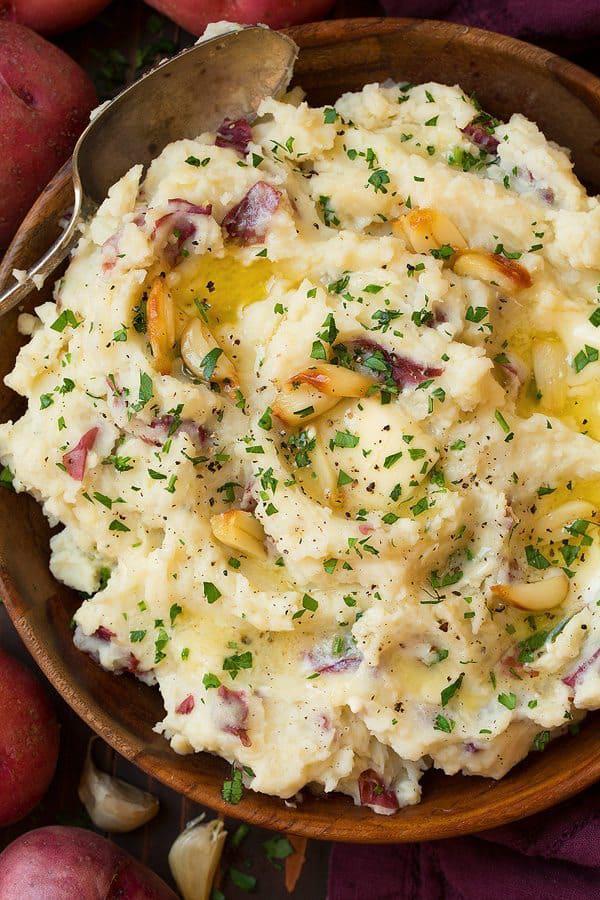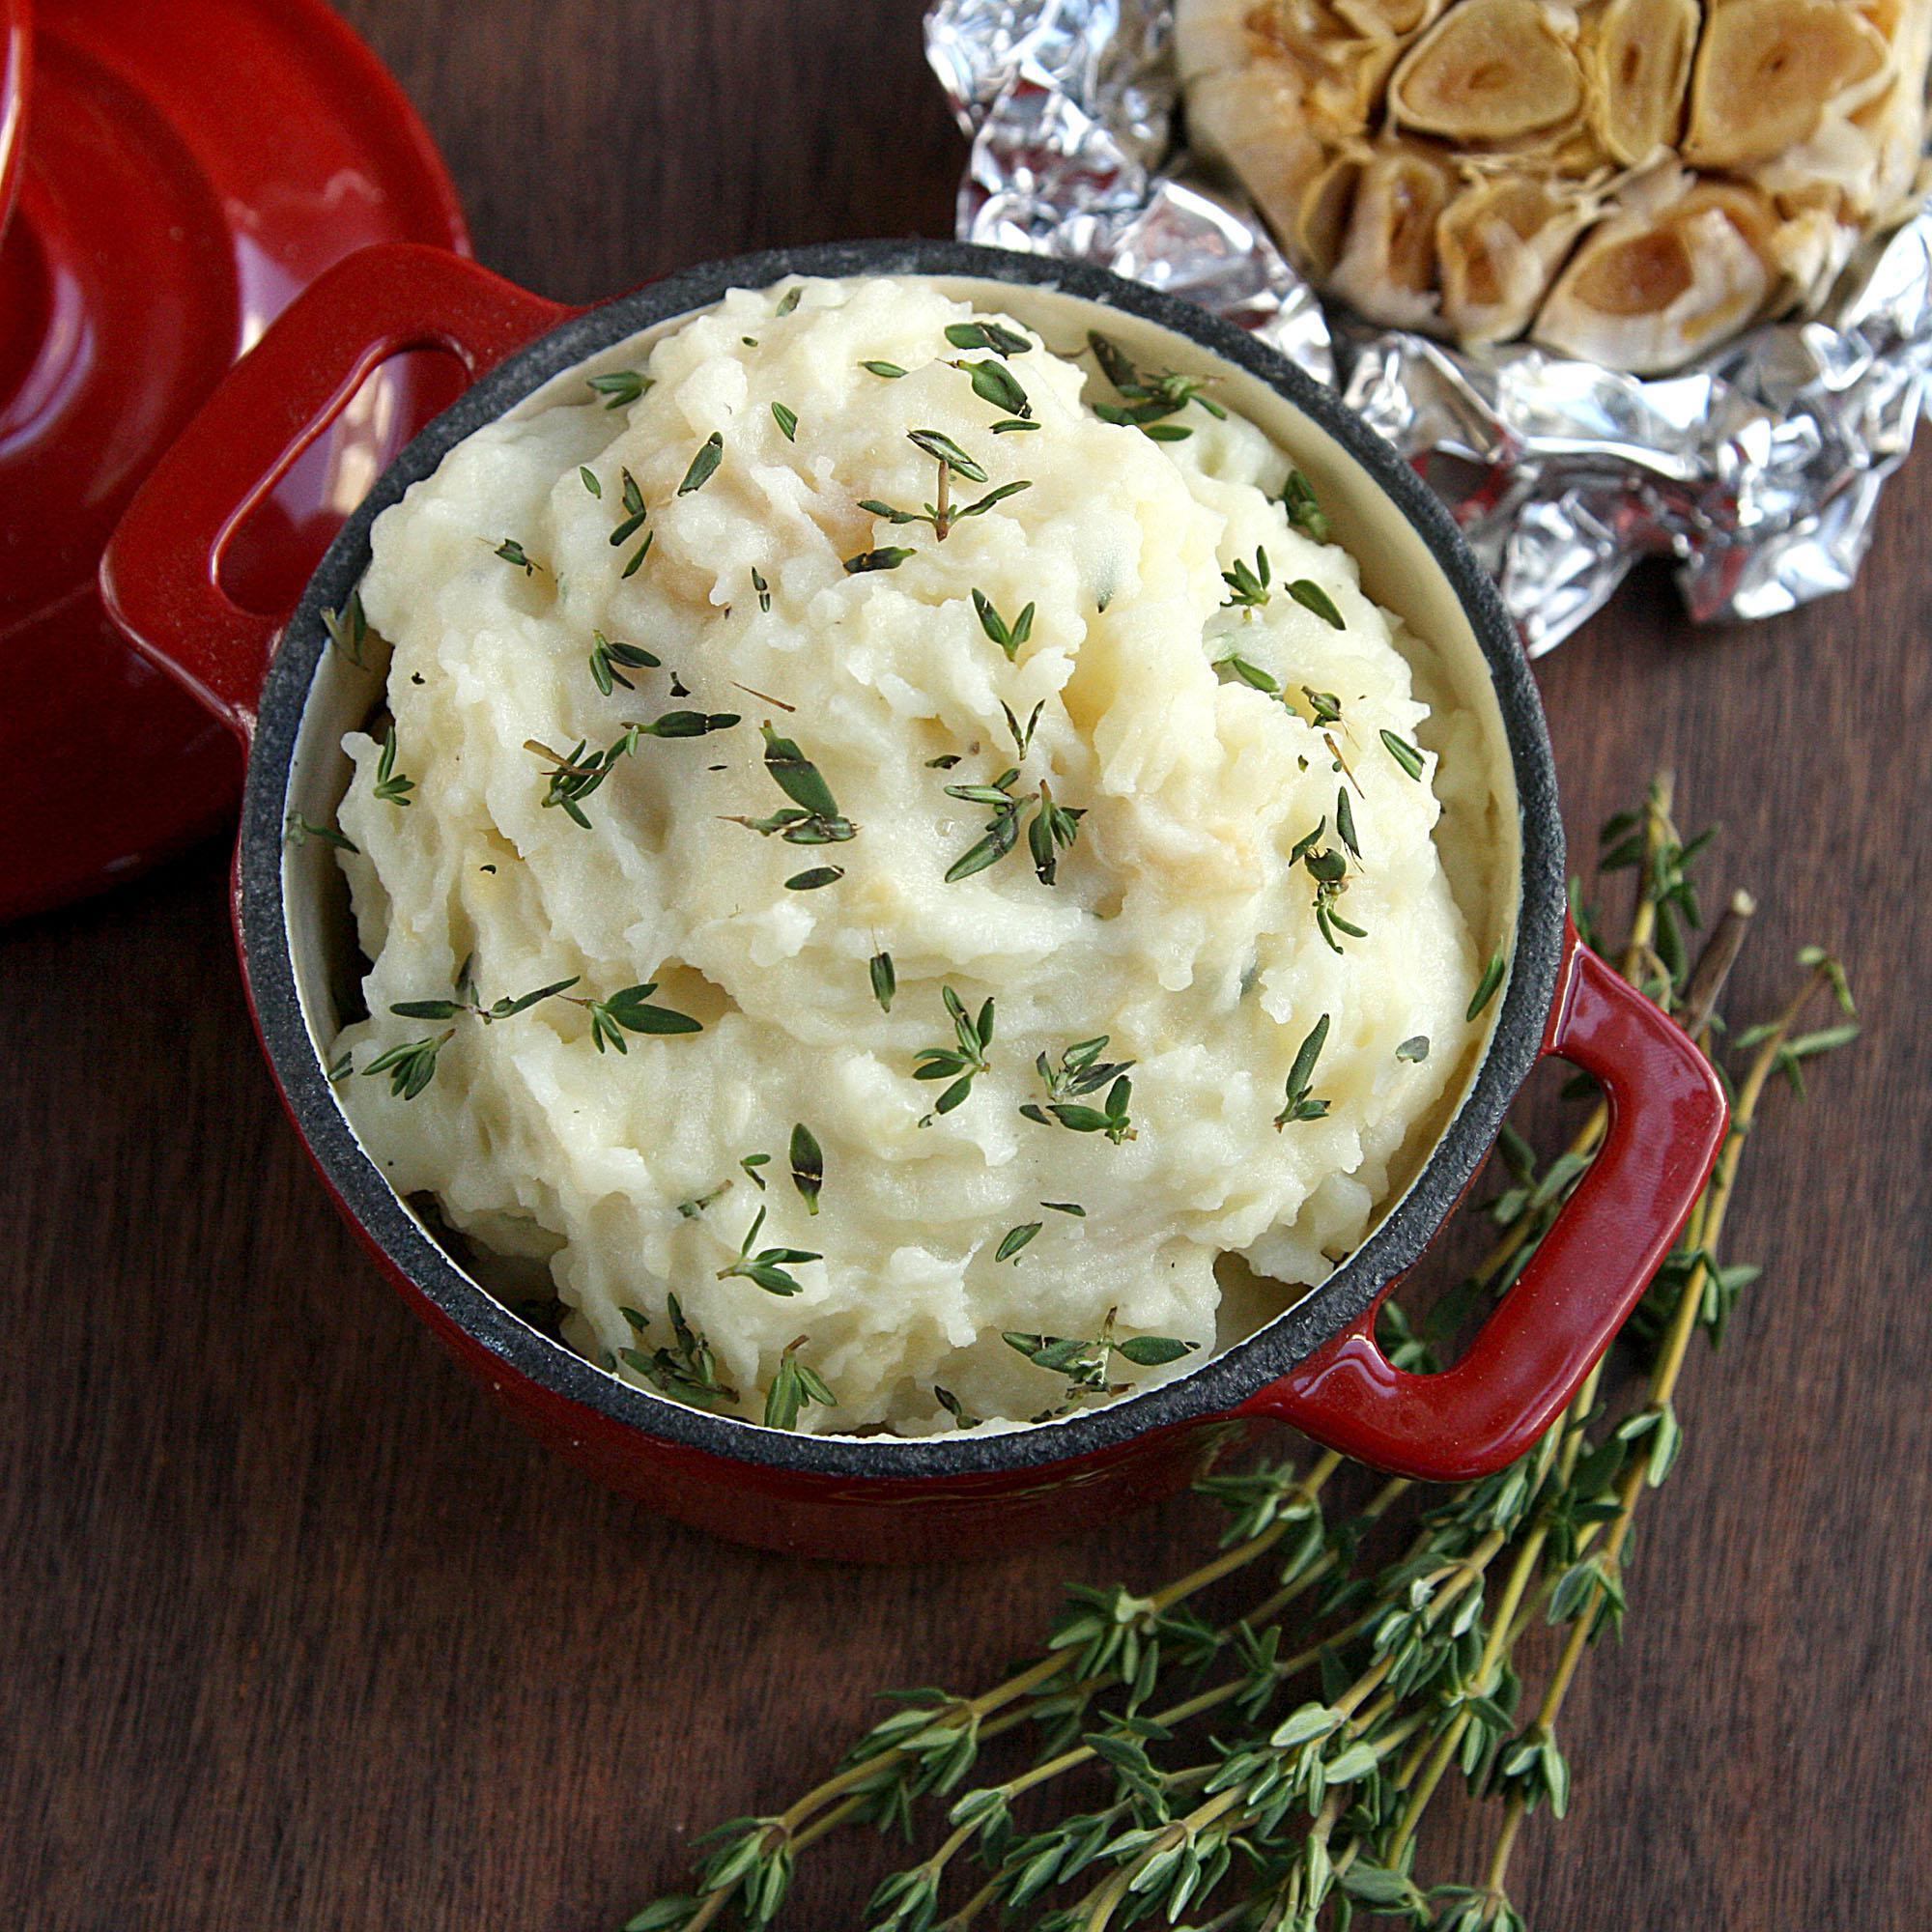The first image is the image on the left, the second image is the image on the right. For the images displayed, is the sentence "Each image shows mashed potatoes on a round white dish, at least one image shows brown broth over the potatoes, and a piece of silverware is to the right of one dish." factually correct? Answer yes or no. No. The first image is the image on the left, the second image is the image on the right. Examine the images to the left and right. Is the description "In one image, brown gravy and a spring of chive are on mashed potatoes in a white bowl." accurate? Answer yes or no. No. 